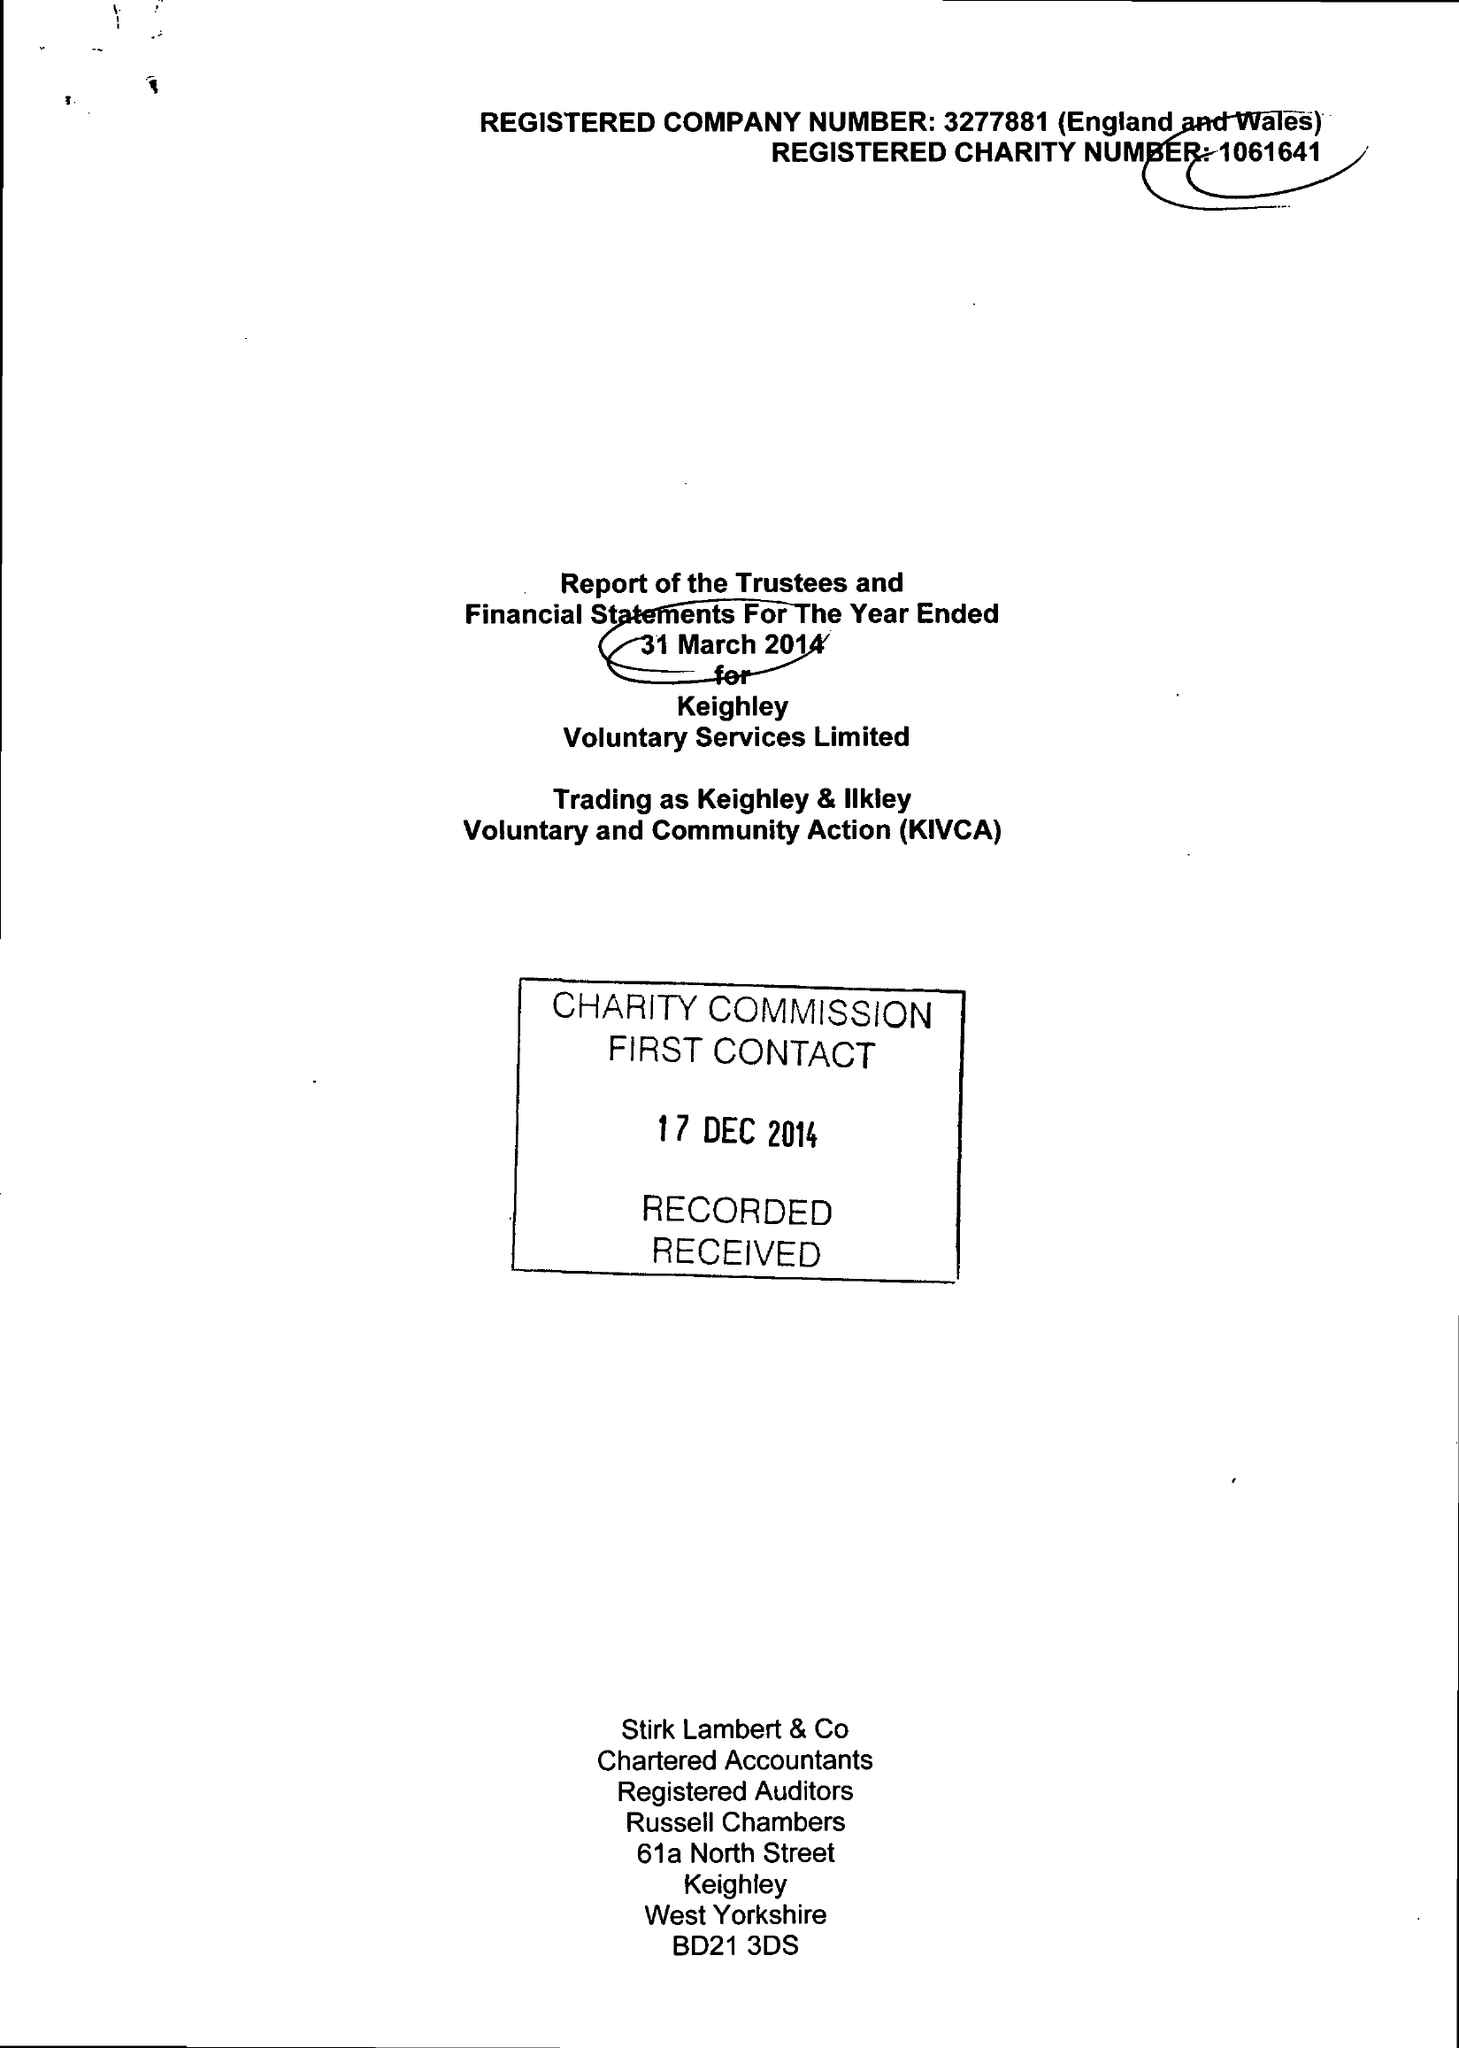What is the value for the address__postcode?
Answer the question using a single word or phrase. BD21 3JD 